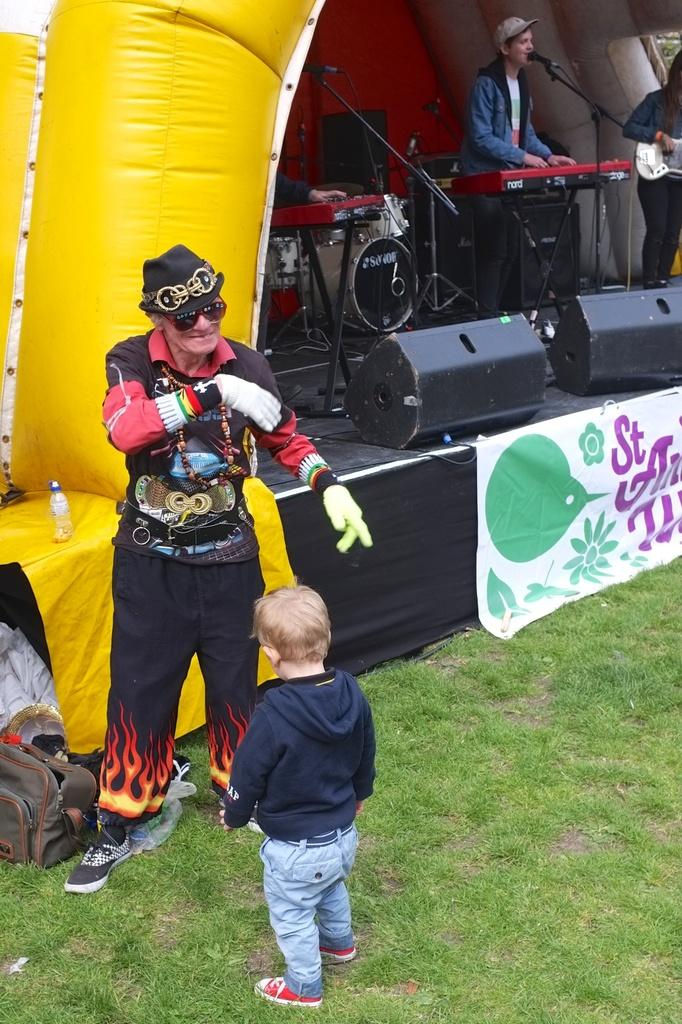What is the kid in the image wearing? The kid is wearing a blue hoodie in the image. What is the setting of the image? The kid is standing on a grass field. Who else is present in the image? There is an old man in the image. How are the old man and the kid positioned in relation to each other? The old man is in front of the kid. What else can be seen in the image? There is a stage in the image, and two people are playing music instruments on the stage. What type of skirt is the worm wearing in the image? There is no worm or skirt present in the image. 